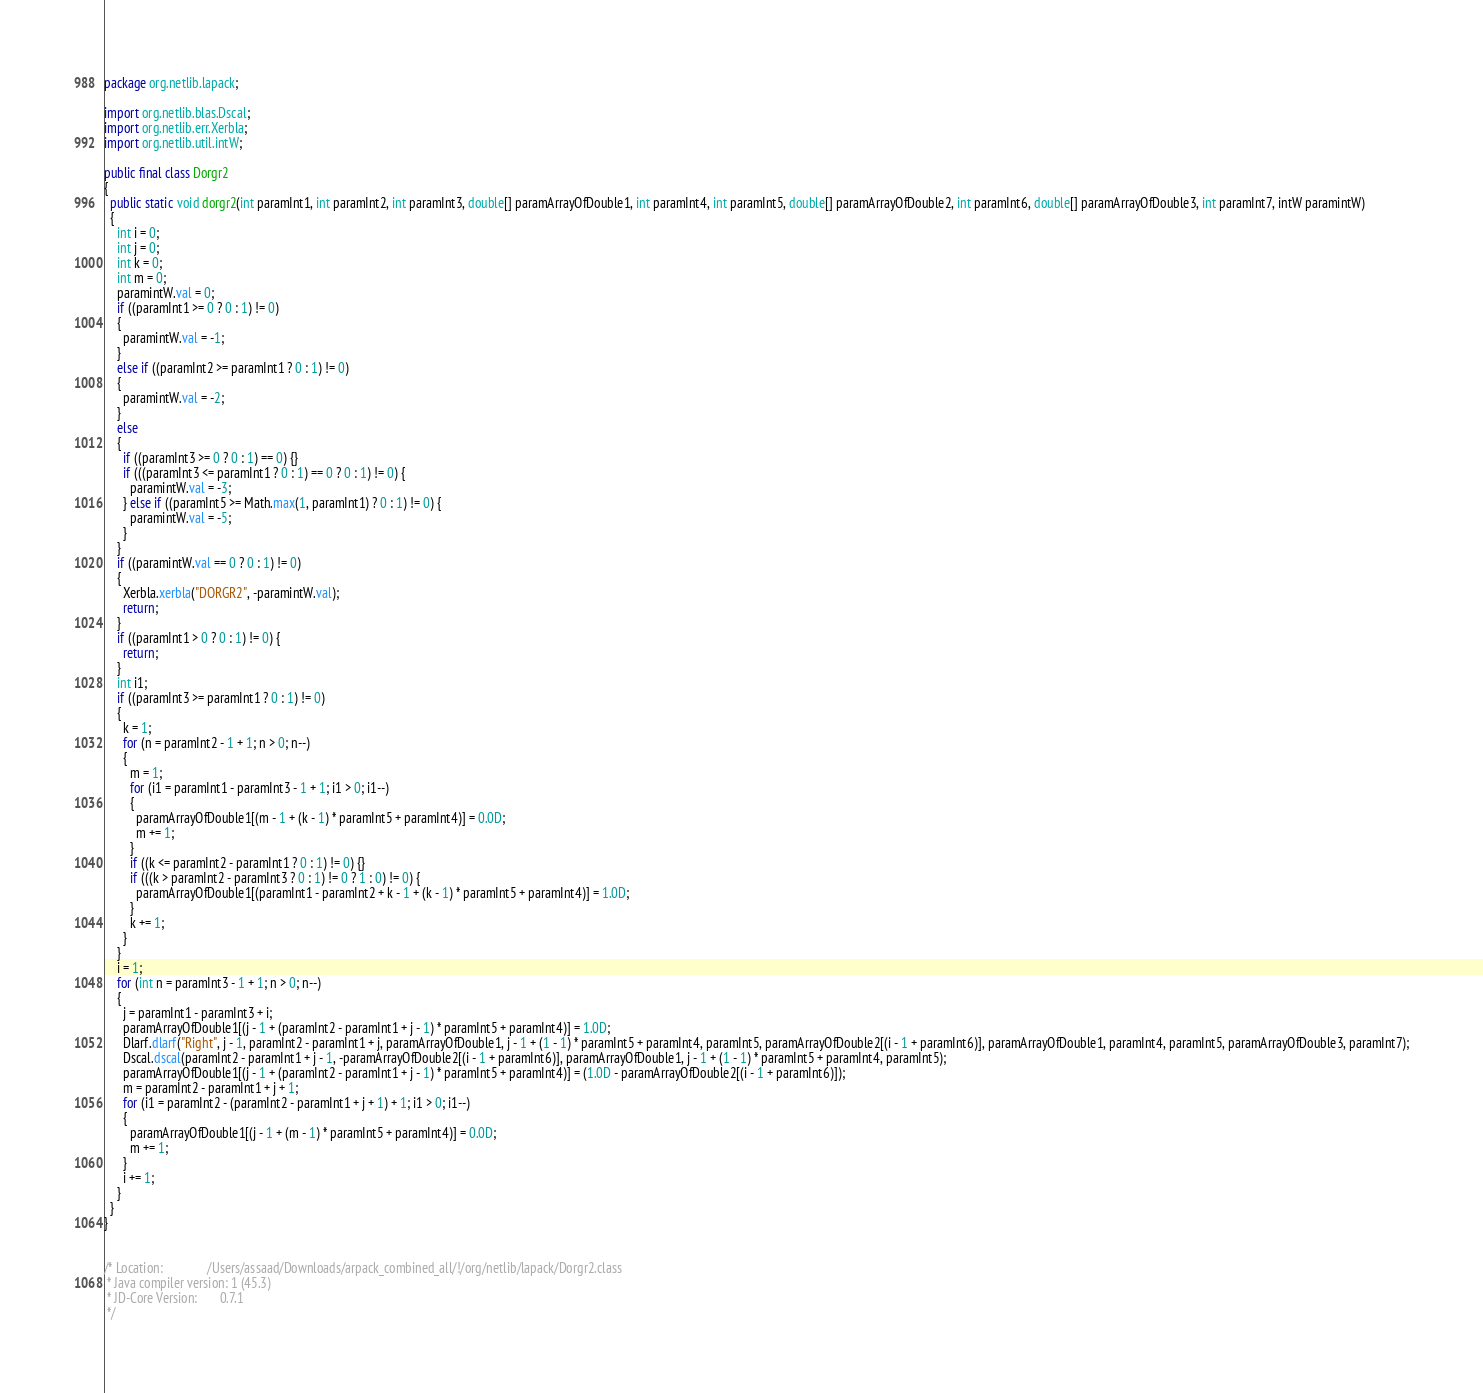<code> <loc_0><loc_0><loc_500><loc_500><_Java_>package org.netlib.lapack;

import org.netlib.blas.Dscal;
import org.netlib.err.Xerbla;
import org.netlib.util.intW;

public final class Dorgr2
{
  public static void dorgr2(int paramInt1, int paramInt2, int paramInt3, double[] paramArrayOfDouble1, int paramInt4, int paramInt5, double[] paramArrayOfDouble2, int paramInt6, double[] paramArrayOfDouble3, int paramInt7, intW paramintW)
  {
    int i = 0;
    int j = 0;
    int k = 0;
    int m = 0;
    paramintW.val = 0;
    if ((paramInt1 >= 0 ? 0 : 1) != 0)
    {
      paramintW.val = -1;
    }
    else if ((paramInt2 >= paramInt1 ? 0 : 1) != 0)
    {
      paramintW.val = -2;
    }
    else
    {
      if ((paramInt3 >= 0 ? 0 : 1) == 0) {}
      if (((paramInt3 <= paramInt1 ? 0 : 1) == 0 ? 0 : 1) != 0) {
        paramintW.val = -3;
      } else if ((paramInt5 >= Math.max(1, paramInt1) ? 0 : 1) != 0) {
        paramintW.val = -5;
      }
    }
    if ((paramintW.val == 0 ? 0 : 1) != 0)
    {
      Xerbla.xerbla("DORGR2", -paramintW.val);
      return;
    }
    if ((paramInt1 > 0 ? 0 : 1) != 0) {
      return;
    }
    int i1;
    if ((paramInt3 >= paramInt1 ? 0 : 1) != 0)
    {
      k = 1;
      for (n = paramInt2 - 1 + 1; n > 0; n--)
      {
        m = 1;
        for (i1 = paramInt1 - paramInt3 - 1 + 1; i1 > 0; i1--)
        {
          paramArrayOfDouble1[(m - 1 + (k - 1) * paramInt5 + paramInt4)] = 0.0D;
          m += 1;
        }
        if ((k <= paramInt2 - paramInt1 ? 0 : 1) != 0) {}
        if (((k > paramInt2 - paramInt3 ? 0 : 1) != 0 ? 1 : 0) != 0) {
          paramArrayOfDouble1[(paramInt1 - paramInt2 + k - 1 + (k - 1) * paramInt5 + paramInt4)] = 1.0D;
        }
        k += 1;
      }
    }
    i = 1;
    for (int n = paramInt3 - 1 + 1; n > 0; n--)
    {
      j = paramInt1 - paramInt3 + i;
      paramArrayOfDouble1[(j - 1 + (paramInt2 - paramInt1 + j - 1) * paramInt5 + paramInt4)] = 1.0D;
      Dlarf.dlarf("Right", j - 1, paramInt2 - paramInt1 + j, paramArrayOfDouble1, j - 1 + (1 - 1) * paramInt5 + paramInt4, paramInt5, paramArrayOfDouble2[(i - 1 + paramInt6)], paramArrayOfDouble1, paramInt4, paramInt5, paramArrayOfDouble3, paramInt7);
      Dscal.dscal(paramInt2 - paramInt1 + j - 1, -paramArrayOfDouble2[(i - 1 + paramInt6)], paramArrayOfDouble1, j - 1 + (1 - 1) * paramInt5 + paramInt4, paramInt5);
      paramArrayOfDouble1[(j - 1 + (paramInt2 - paramInt1 + j - 1) * paramInt5 + paramInt4)] = (1.0D - paramArrayOfDouble2[(i - 1 + paramInt6)]);
      m = paramInt2 - paramInt1 + j + 1;
      for (i1 = paramInt2 - (paramInt2 - paramInt1 + j + 1) + 1; i1 > 0; i1--)
      {
        paramArrayOfDouble1[(j - 1 + (m - 1) * paramInt5 + paramInt4)] = 0.0D;
        m += 1;
      }
      i += 1;
    }
  }
}


/* Location:              /Users/assaad/Downloads/arpack_combined_all/!/org/netlib/lapack/Dorgr2.class
 * Java compiler version: 1 (45.3)
 * JD-Core Version:       0.7.1
 */</code> 